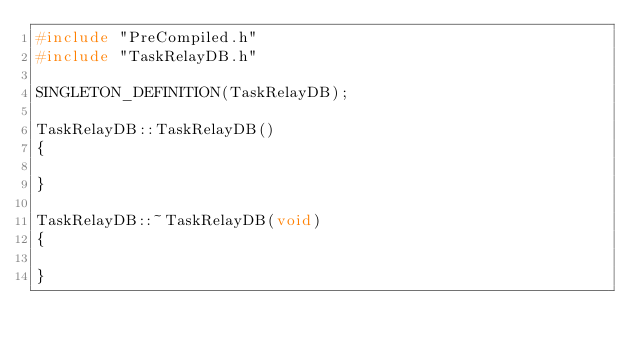Convert code to text. <code><loc_0><loc_0><loc_500><loc_500><_C++_>#include "PreCompiled.h"
#include "TaskRelayDB.h"

SINGLETON_DEFINITION(TaskRelayDB);

TaskRelayDB::TaskRelayDB()
{

}

TaskRelayDB::~TaskRelayDB(void)
{

}
</code> 